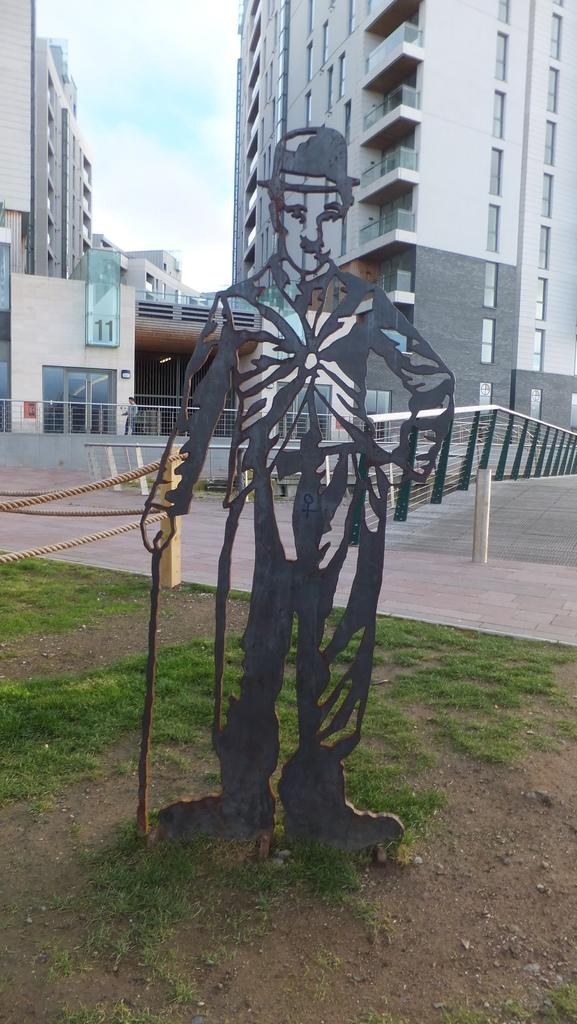What type of surface can be seen in the image? There is a road in the image. What structures are present in the image? There are big buildings in the image. What additional object can be seen in the image? There is a statue in the image. What is the purpose of the board in the image? The purpose of the board in the image is not specified, but it could be for displaying information or advertisements. What are the two poles used for in the image? The two poles in the image have two threads attached to them, which suggests they might be used for hanging something or as part of a sign or display. What type of vegetation is present in the image? There is grass on the land in the image. What is visible at the top of the image? The sky is visible at the top of the image. What type of crime is being committed in the image? There is no indication of any crime being committed in the image. What is the quill used for in the image? There is no quill present in the image. 